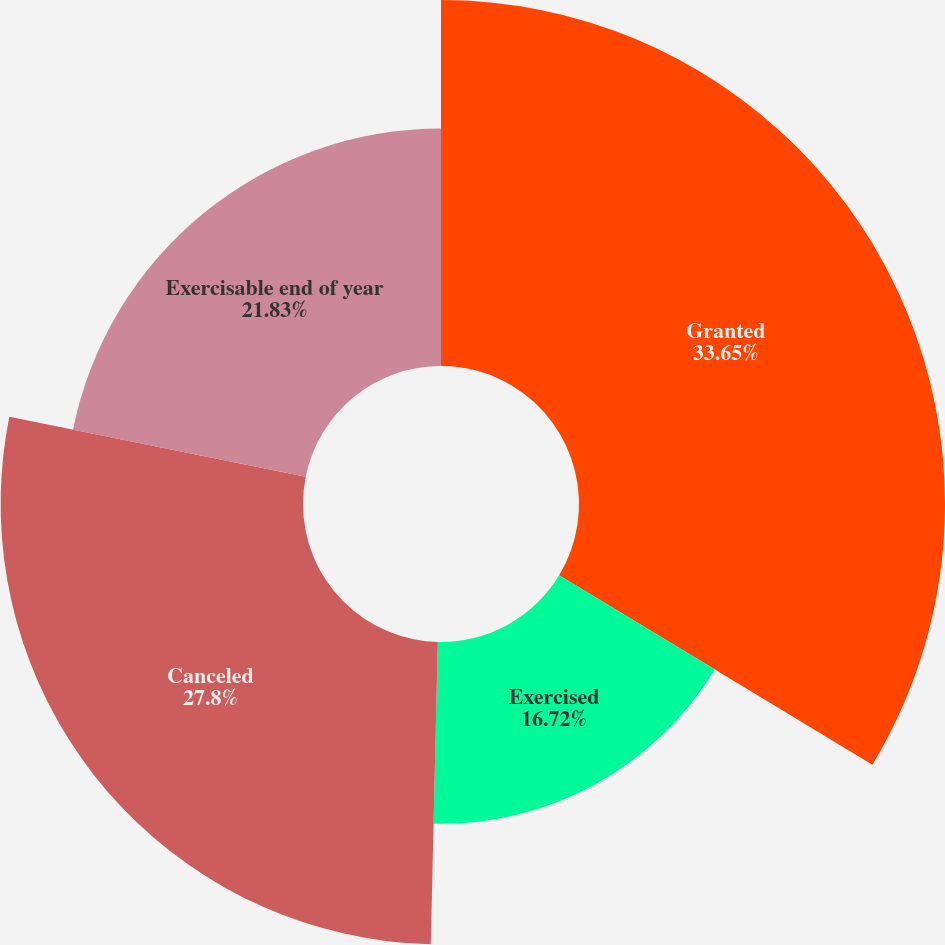Convert chart to OTSL. <chart><loc_0><loc_0><loc_500><loc_500><pie_chart><fcel>Granted<fcel>Exercised<fcel>Canceled<fcel>Exercisable end of year<nl><fcel>33.65%<fcel>16.72%<fcel>27.8%<fcel>21.83%<nl></chart> 